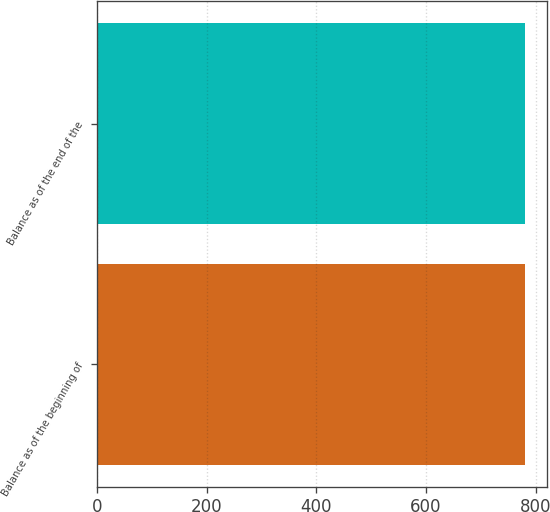<chart> <loc_0><loc_0><loc_500><loc_500><bar_chart><fcel>Balance as of the beginning of<fcel>Balance as of the end of the<nl><fcel>781<fcel>781.1<nl></chart> 